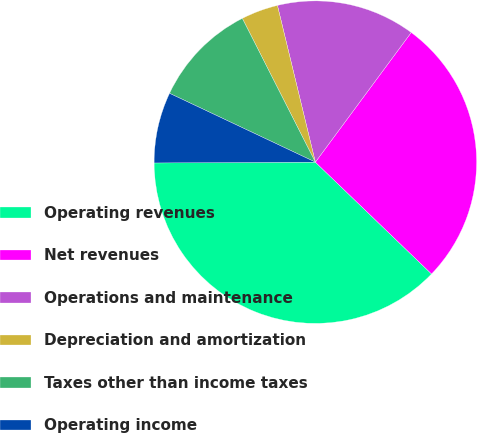Convert chart to OTSL. <chart><loc_0><loc_0><loc_500><loc_500><pie_chart><fcel>Operating revenues<fcel>Net revenues<fcel>Operations and maintenance<fcel>Depreciation and amortization<fcel>Taxes other than income taxes<fcel>Operating income<nl><fcel>37.72%<fcel>27.06%<fcel>13.91%<fcel>3.7%<fcel>10.5%<fcel>7.1%<nl></chart> 